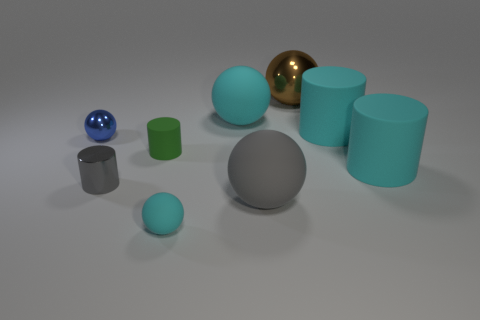Subtract all gray cylinders. How many cylinders are left? 3 Subtract all cyan balls. How many balls are left? 3 Subtract all balls. How many objects are left? 4 Subtract 4 spheres. How many spheres are left? 1 Subtract all gray balls. Subtract all yellow cylinders. How many balls are left? 4 Subtract all gray cubes. How many green cylinders are left? 1 Subtract all cyan things. Subtract all big cyan rubber balls. How many objects are left? 4 Add 6 small objects. How many small objects are left? 10 Add 1 large gray rubber things. How many large gray rubber things exist? 2 Subtract 1 cyan cylinders. How many objects are left? 8 